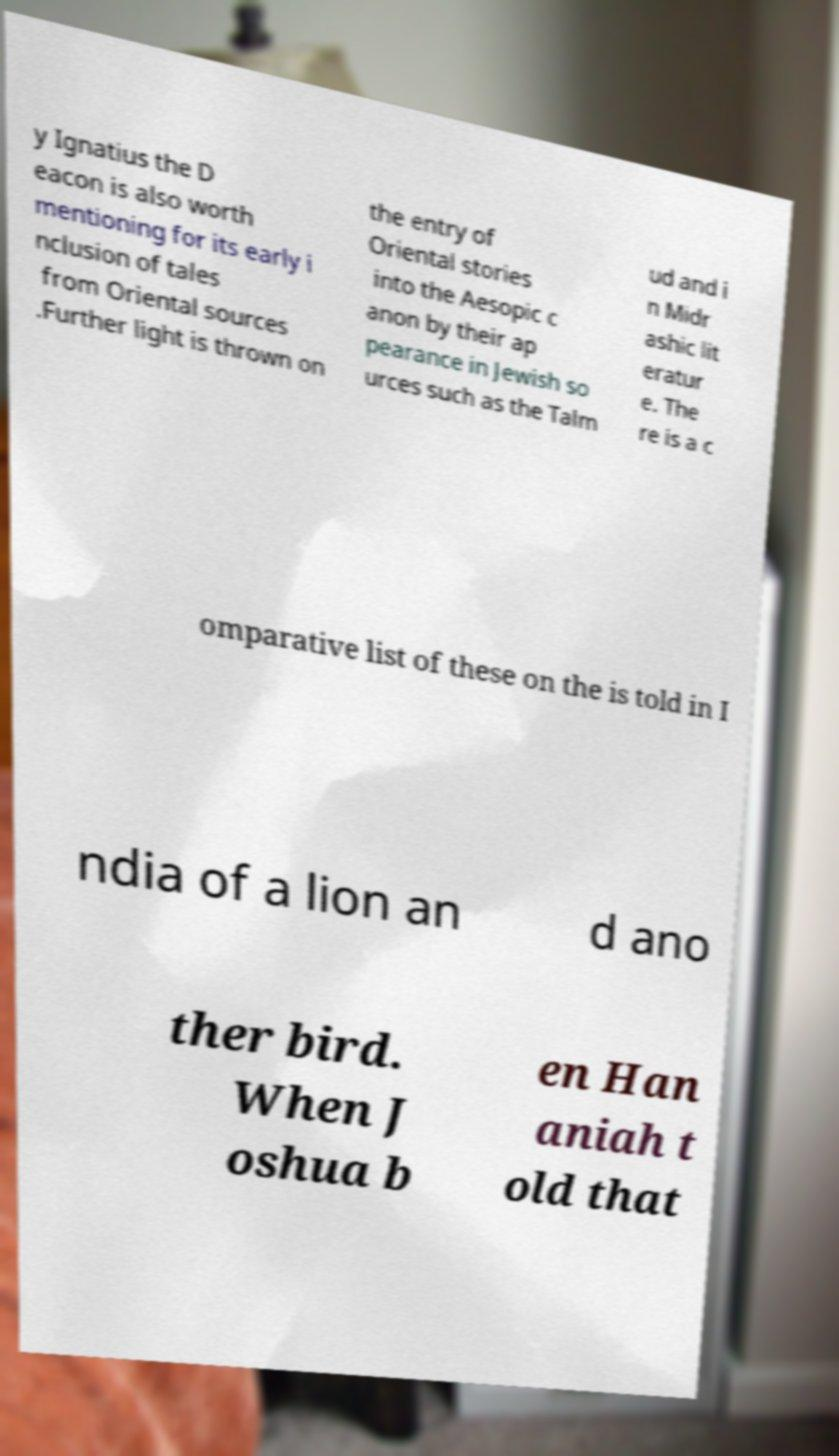Can you accurately transcribe the text from the provided image for me? y Ignatius the D eacon is also worth mentioning for its early i nclusion of tales from Oriental sources .Further light is thrown on the entry of Oriental stories into the Aesopic c anon by their ap pearance in Jewish so urces such as the Talm ud and i n Midr ashic lit eratur e. The re is a c omparative list of these on the is told in I ndia of a lion an d ano ther bird. When J oshua b en Han aniah t old that 